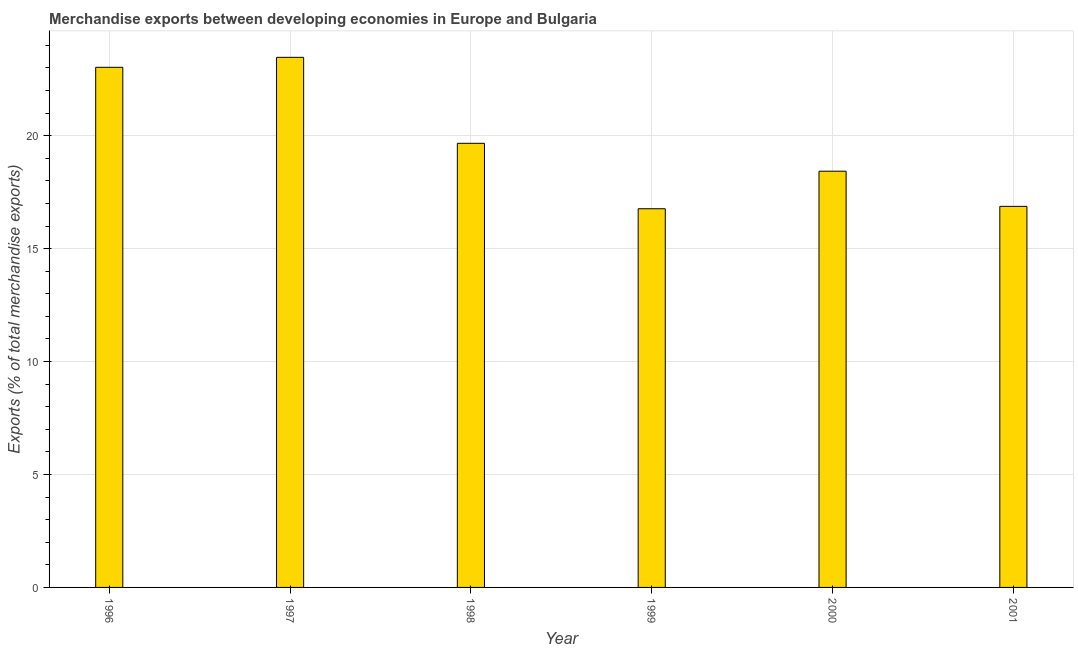Does the graph contain any zero values?
Your answer should be very brief. No. What is the title of the graph?
Make the answer very short. Merchandise exports between developing economies in Europe and Bulgaria. What is the label or title of the Y-axis?
Your answer should be very brief. Exports (% of total merchandise exports). What is the merchandise exports in 2001?
Ensure brevity in your answer.  16.87. Across all years, what is the maximum merchandise exports?
Keep it short and to the point. 23.47. Across all years, what is the minimum merchandise exports?
Your response must be concise. 16.77. In which year was the merchandise exports maximum?
Offer a very short reply. 1997. What is the sum of the merchandise exports?
Keep it short and to the point. 118.23. What is the difference between the merchandise exports in 1999 and 2001?
Give a very brief answer. -0.1. What is the average merchandise exports per year?
Offer a very short reply. 19.7. What is the median merchandise exports?
Offer a terse response. 19.05. Do a majority of the years between 1998 and 2000 (inclusive) have merchandise exports greater than 10 %?
Your answer should be compact. Yes. What is the ratio of the merchandise exports in 1996 to that in 1998?
Offer a terse response. 1.17. Is the merchandise exports in 1996 less than that in 2001?
Your answer should be compact. No. Is the difference between the merchandise exports in 1999 and 2001 greater than the difference between any two years?
Keep it short and to the point. No. What is the difference between the highest and the second highest merchandise exports?
Offer a very short reply. 0.44. What is the difference between the highest and the lowest merchandise exports?
Make the answer very short. 6.7. In how many years, is the merchandise exports greater than the average merchandise exports taken over all years?
Your answer should be very brief. 2. What is the Exports (% of total merchandise exports) of 1996?
Provide a short and direct response. 23.03. What is the Exports (% of total merchandise exports) in 1997?
Give a very brief answer. 23.47. What is the Exports (% of total merchandise exports) in 1998?
Offer a terse response. 19.66. What is the Exports (% of total merchandise exports) of 1999?
Offer a very short reply. 16.77. What is the Exports (% of total merchandise exports) in 2000?
Give a very brief answer. 18.43. What is the Exports (% of total merchandise exports) in 2001?
Make the answer very short. 16.87. What is the difference between the Exports (% of total merchandise exports) in 1996 and 1997?
Give a very brief answer. -0.44. What is the difference between the Exports (% of total merchandise exports) in 1996 and 1998?
Provide a short and direct response. 3.36. What is the difference between the Exports (% of total merchandise exports) in 1996 and 1999?
Your answer should be very brief. 6.26. What is the difference between the Exports (% of total merchandise exports) in 1996 and 2000?
Offer a terse response. 4.6. What is the difference between the Exports (% of total merchandise exports) in 1996 and 2001?
Give a very brief answer. 6.16. What is the difference between the Exports (% of total merchandise exports) in 1997 and 1998?
Provide a succinct answer. 3.81. What is the difference between the Exports (% of total merchandise exports) in 1997 and 1999?
Offer a terse response. 6.7. What is the difference between the Exports (% of total merchandise exports) in 1997 and 2000?
Your response must be concise. 5.04. What is the difference between the Exports (% of total merchandise exports) in 1997 and 2001?
Provide a succinct answer. 6.6. What is the difference between the Exports (% of total merchandise exports) in 1998 and 1999?
Make the answer very short. 2.9. What is the difference between the Exports (% of total merchandise exports) in 1998 and 2000?
Your answer should be very brief. 1.23. What is the difference between the Exports (% of total merchandise exports) in 1998 and 2001?
Ensure brevity in your answer.  2.79. What is the difference between the Exports (% of total merchandise exports) in 1999 and 2000?
Your answer should be compact. -1.66. What is the difference between the Exports (% of total merchandise exports) in 1999 and 2001?
Give a very brief answer. -0.11. What is the difference between the Exports (% of total merchandise exports) in 2000 and 2001?
Your answer should be compact. 1.56. What is the ratio of the Exports (% of total merchandise exports) in 1996 to that in 1997?
Provide a short and direct response. 0.98. What is the ratio of the Exports (% of total merchandise exports) in 1996 to that in 1998?
Offer a terse response. 1.17. What is the ratio of the Exports (% of total merchandise exports) in 1996 to that in 1999?
Provide a succinct answer. 1.37. What is the ratio of the Exports (% of total merchandise exports) in 1996 to that in 2001?
Offer a very short reply. 1.36. What is the ratio of the Exports (% of total merchandise exports) in 1997 to that in 1998?
Give a very brief answer. 1.19. What is the ratio of the Exports (% of total merchandise exports) in 1997 to that in 2000?
Offer a terse response. 1.27. What is the ratio of the Exports (% of total merchandise exports) in 1997 to that in 2001?
Offer a very short reply. 1.39. What is the ratio of the Exports (% of total merchandise exports) in 1998 to that in 1999?
Ensure brevity in your answer.  1.17. What is the ratio of the Exports (% of total merchandise exports) in 1998 to that in 2000?
Keep it short and to the point. 1.07. What is the ratio of the Exports (% of total merchandise exports) in 1998 to that in 2001?
Your response must be concise. 1.17. What is the ratio of the Exports (% of total merchandise exports) in 1999 to that in 2000?
Ensure brevity in your answer.  0.91. What is the ratio of the Exports (% of total merchandise exports) in 1999 to that in 2001?
Ensure brevity in your answer.  0.99. What is the ratio of the Exports (% of total merchandise exports) in 2000 to that in 2001?
Provide a succinct answer. 1.09. 